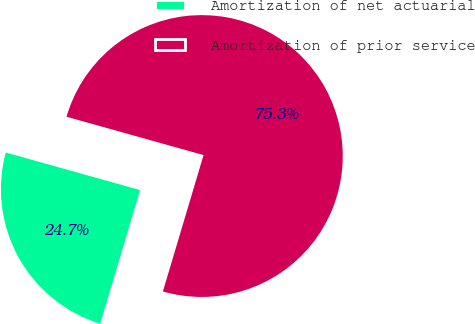<chart> <loc_0><loc_0><loc_500><loc_500><pie_chart><fcel>Amortization of net actuarial<fcel>Amortization of prior service<nl><fcel>24.73%<fcel>75.27%<nl></chart> 